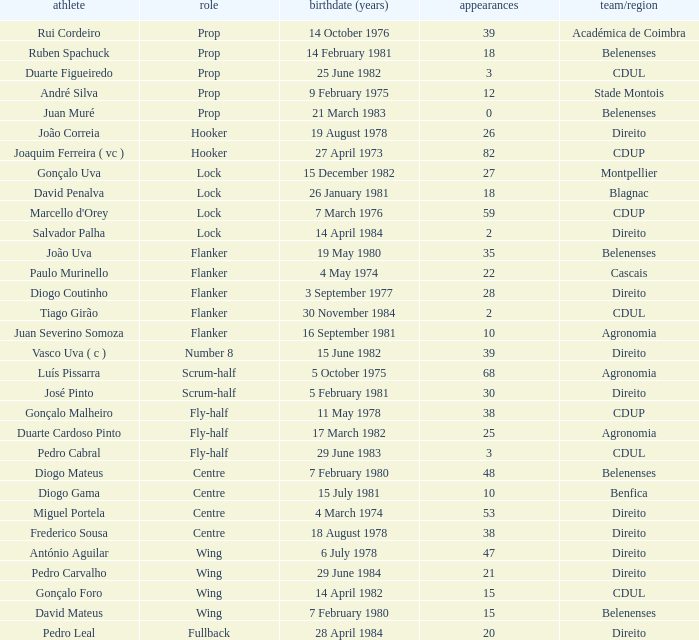How many caps have a Position of prop, and a Player of rui cordeiro? 1.0. 